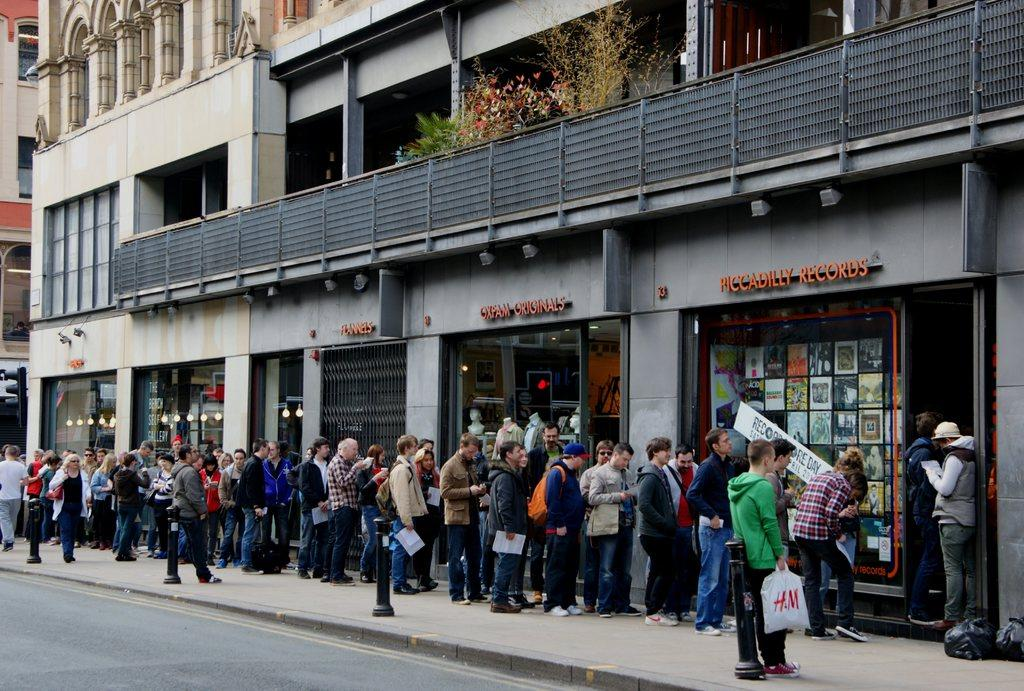<image>
Share a concise interpretation of the image provided. People are lined up outside of Piccadilly Records, including someone with an H&M bag. 